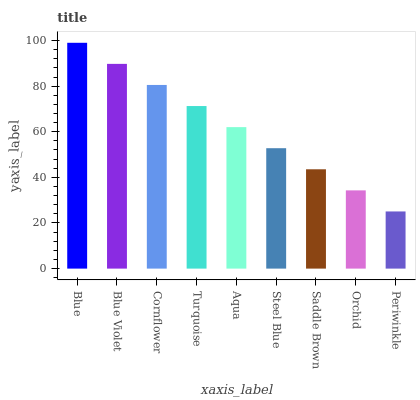Is Periwinkle the minimum?
Answer yes or no. Yes. Is Blue the maximum?
Answer yes or no. Yes. Is Blue Violet the minimum?
Answer yes or no. No. Is Blue Violet the maximum?
Answer yes or no. No. Is Blue greater than Blue Violet?
Answer yes or no. Yes. Is Blue Violet less than Blue?
Answer yes or no. Yes. Is Blue Violet greater than Blue?
Answer yes or no. No. Is Blue less than Blue Violet?
Answer yes or no. No. Is Aqua the high median?
Answer yes or no. Yes. Is Aqua the low median?
Answer yes or no. Yes. Is Blue the high median?
Answer yes or no. No. Is Periwinkle the low median?
Answer yes or no. No. 